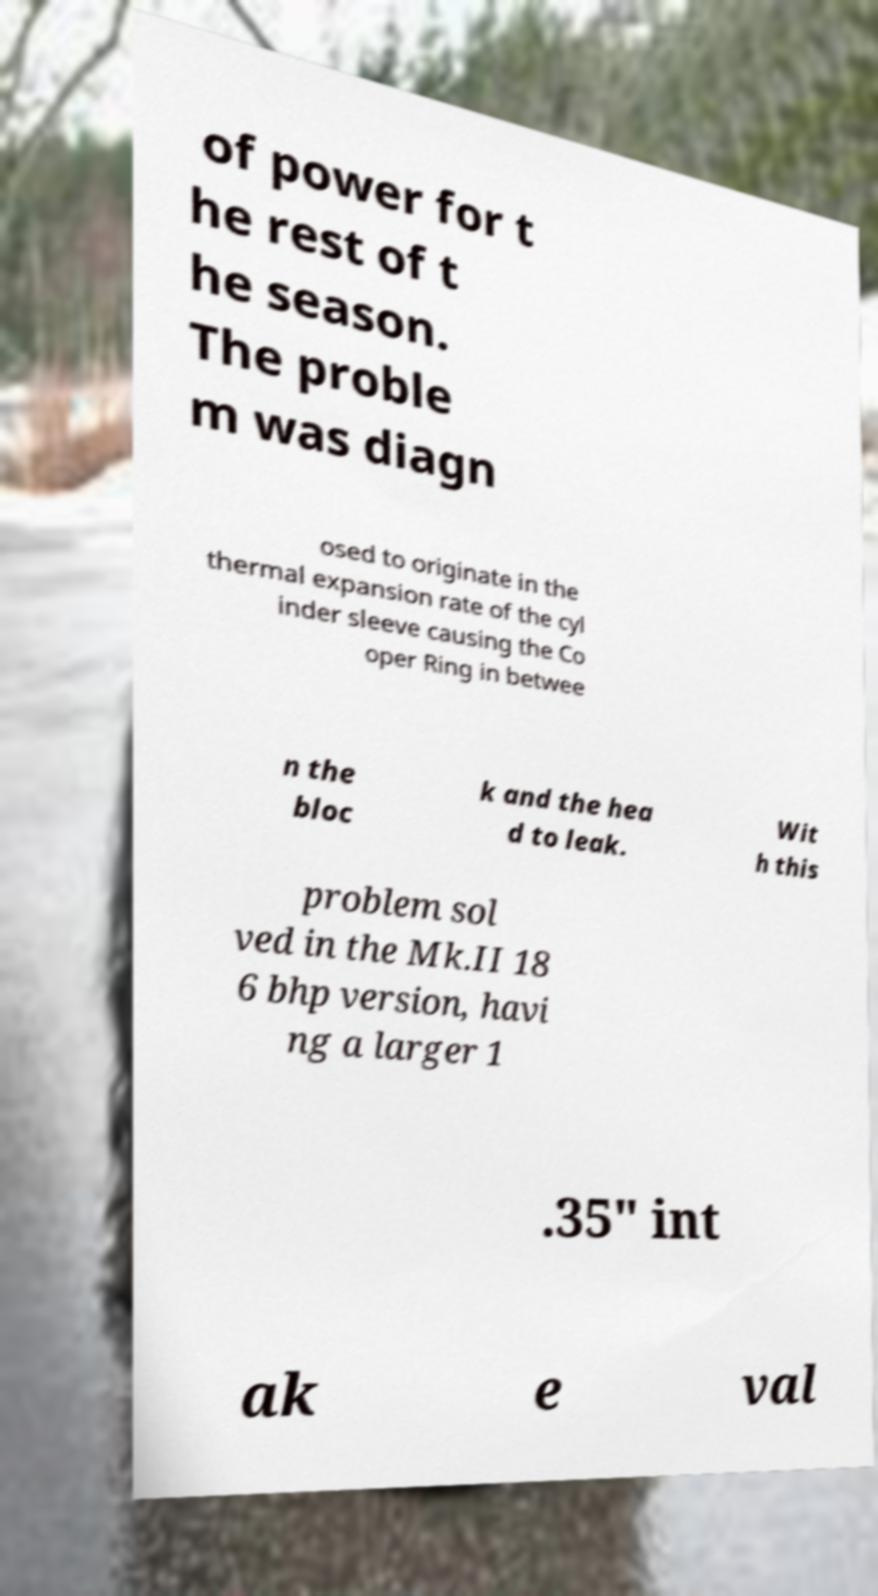I need the written content from this picture converted into text. Can you do that? of power for t he rest of t he season. The proble m was diagn osed to originate in the thermal expansion rate of the cyl inder sleeve causing the Co oper Ring in betwee n the bloc k and the hea d to leak. Wit h this problem sol ved in the Mk.II 18 6 bhp version, havi ng a larger 1 .35" int ak e val 